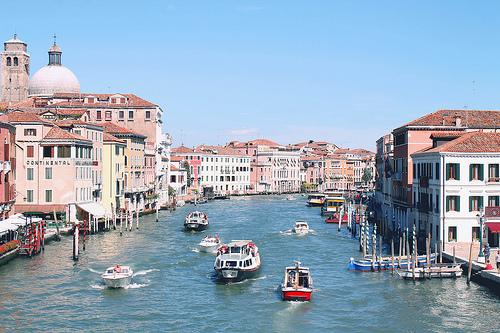Describe the scene depicted in the image with emphasis on colors and object locations. Various colored boats in the water, tall buildings with red roofs by the canal, a blue and clear sky, and pink striped pylons in the water. Discuss the notable aspects of the sky and water in the image. The sky is clear and mostly blue, and the body of water is blue with boats and striped water poles. Point out the interesting elements observed in the image. Red and black marker, a white dome on a building, a cross on top of a building, boat moving on water, and four striped poles in the water row. Mention the objects in the image that are near the water and provide their colors. Blue boat by the dock, tall buildings near water, red and black marker, orange and white boat, and blue and white boats. Mention the dominant features of the image, including objects, colors, and actions. Boats in the water, tall buildings near water, clear sky, red roofs, canal boats docked, blue body of water, person in red sitting, dome church steeple, and striped canal pylons. What are the noticeable colors and the objects they are associated with in the image? Red boat bottom, clear blue sky, pink building, man wearing red, orange and white boat, mostly blue water, and red striped canal pylons. List the unique features of the buildings in the image. Pink contenental building on canal, white building on dock, tall buildings near water, dome church steeple, and bell tower. Explain the differentiating features of the boats in the image. Red bottomed boats, blue boat by dock, orange and white boat, small red and white boat, large black and white boat, and a blue and white boat. Briefly describe the main elements and settings in the image. Boats in water, tall buildings by canal, clear sky, blue body of water, person in red, and dome steeple with cross. 